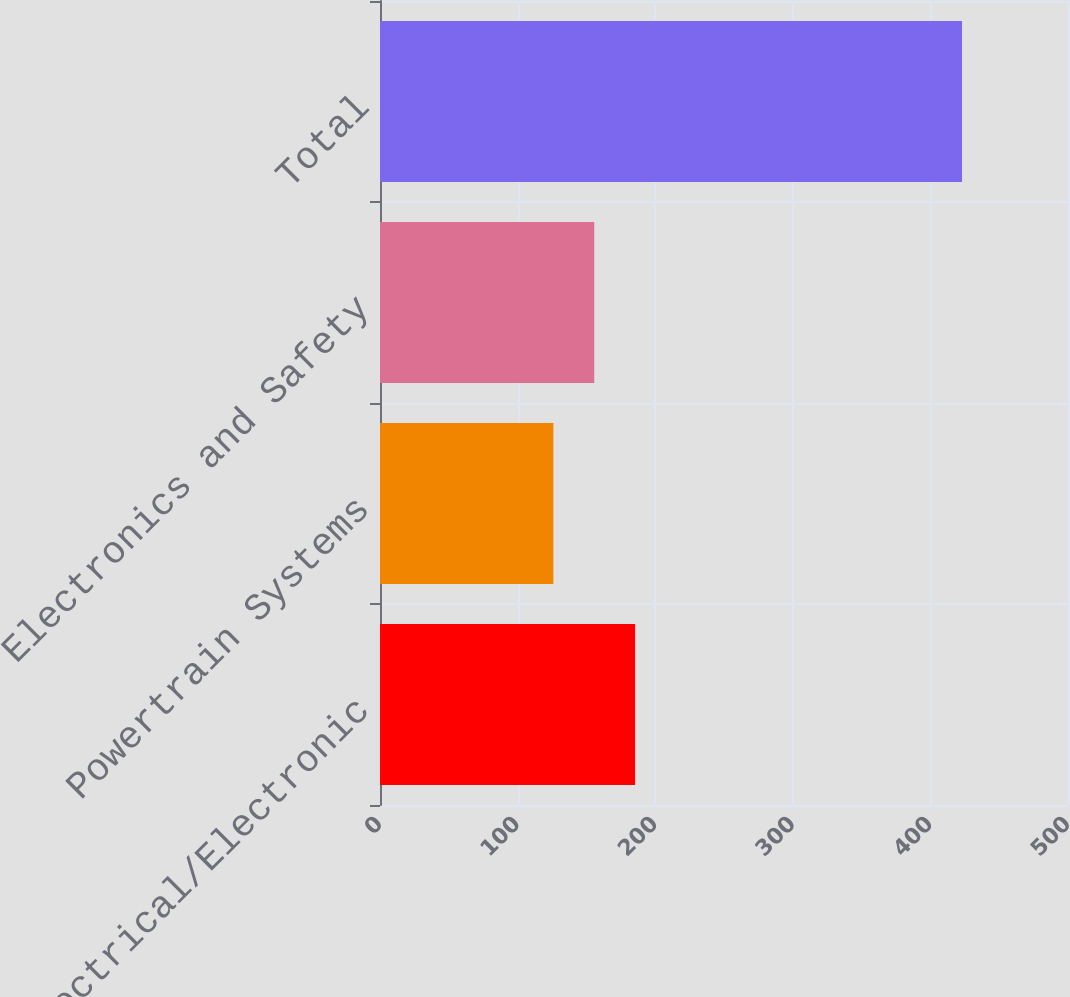Convert chart to OTSL. <chart><loc_0><loc_0><loc_500><loc_500><bar_chart><fcel>Electrical/Electronic<fcel>Powertrain Systems<fcel>Electronics and Safety<fcel>Total<nl><fcel>185.4<fcel>126<fcel>155.7<fcel>423<nl></chart> 